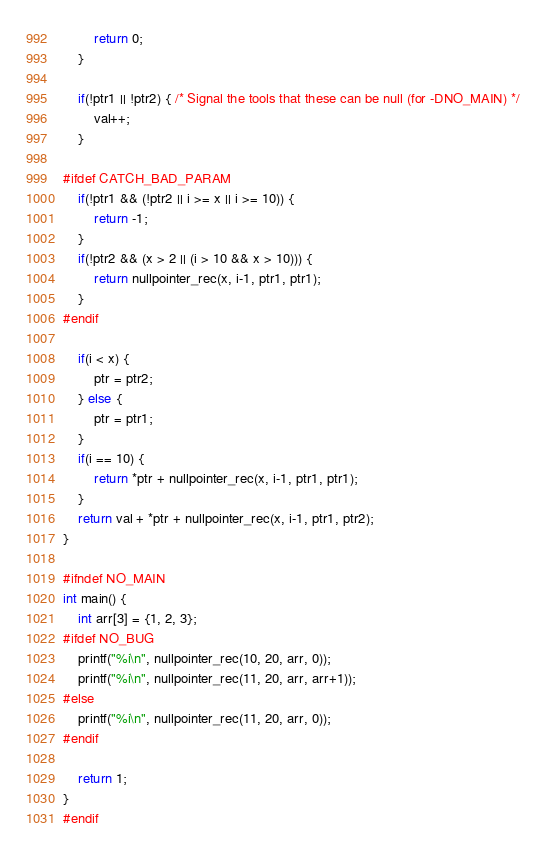Convert code to text. <code><loc_0><loc_0><loc_500><loc_500><_C_>        return 0;
    }

    if(!ptr1 || !ptr2) { /* Signal the tools that these can be null (for -DNO_MAIN) */
        val++;
    }

#ifdef CATCH_BAD_PARAM
    if(!ptr1 && (!ptr2 || i >= x || i >= 10)) {
        return -1;
    }
    if(!ptr2 && (x > 2 || (i > 10 && x > 10))) {
        return nullpointer_rec(x, i-1, ptr1, ptr1);
    }
#endif

    if(i < x) {
        ptr = ptr2;
    } else {
        ptr = ptr1;
    }
    if(i == 10) {
        return *ptr + nullpointer_rec(x, i-1, ptr1, ptr1);
    }
    return val + *ptr + nullpointer_rec(x, i-1, ptr1, ptr2);
}

#ifndef NO_MAIN
int main() {
    int arr[3] = {1, 2, 3};
#ifdef NO_BUG
    printf("%i\n", nullpointer_rec(10, 20, arr, 0));
    printf("%i\n", nullpointer_rec(11, 20, arr, arr+1));
#else
    printf("%i\n", nullpointer_rec(11, 20, arr, 0));
#endif

    return 1;
}
#endif
</code> 